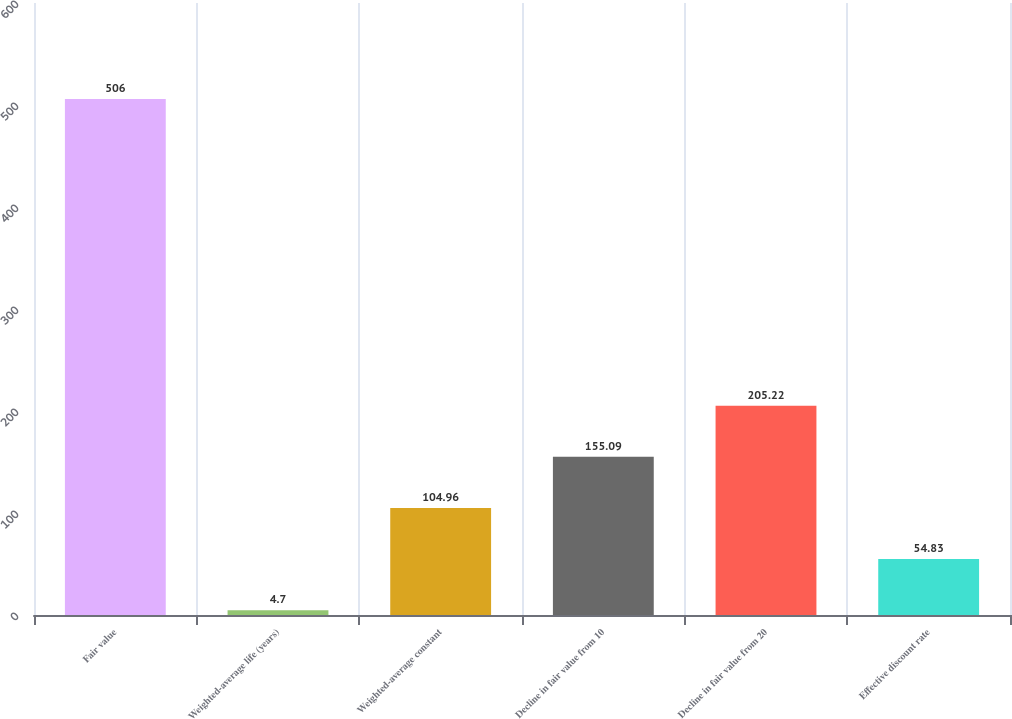Convert chart to OTSL. <chart><loc_0><loc_0><loc_500><loc_500><bar_chart><fcel>Fair value<fcel>Weighted-average life (years)<fcel>Weighted-average constant<fcel>Decline in fair value from 10<fcel>Decline in fair value from 20<fcel>Effective discount rate<nl><fcel>506<fcel>4.7<fcel>104.96<fcel>155.09<fcel>205.22<fcel>54.83<nl></chart> 